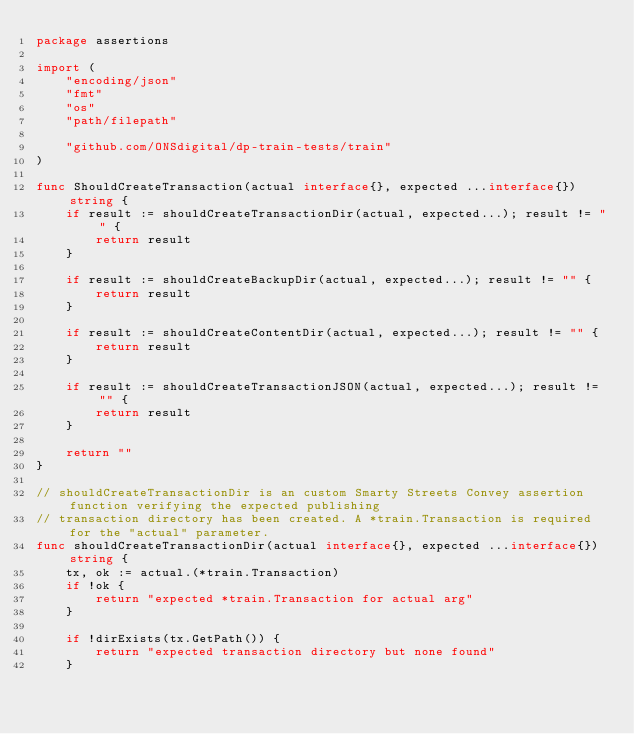Convert code to text. <code><loc_0><loc_0><loc_500><loc_500><_Go_>package assertions

import (
	"encoding/json"
	"fmt"
	"os"
	"path/filepath"

	"github.com/ONSdigital/dp-train-tests/train"
)

func ShouldCreateTransaction(actual interface{}, expected ...interface{}) string {
	if result := shouldCreateTransactionDir(actual, expected...); result != "" {
		return result
	}

	if result := shouldCreateBackupDir(actual, expected...); result != "" {
		return result
	}

	if result := shouldCreateContentDir(actual, expected...); result != "" {
		return result
	}

	if result := shouldCreateTransactionJSON(actual, expected...); result != "" {
		return result
	}

	return ""
}

// shouldCreateTransactionDir is an custom Smarty Streets Convey assertion function verifying the expected publishing
// transaction directory has been created. A *train.Transaction is required for the "actual" parameter.
func shouldCreateTransactionDir(actual interface{}, expected ...interface{}) string {
	tx, ok := actual.(*train.Transaction)
	if !ok {
		return "expected *train.Transaction for actual arg"
	}

	if !dirExists(tx.GetPath()) {
		return "expected transaction directory but none found"
	}
</code> 